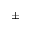Convert formula to latex. <formula><loc_0><loc_0><loc_500><loc_500>\pm</formula> 